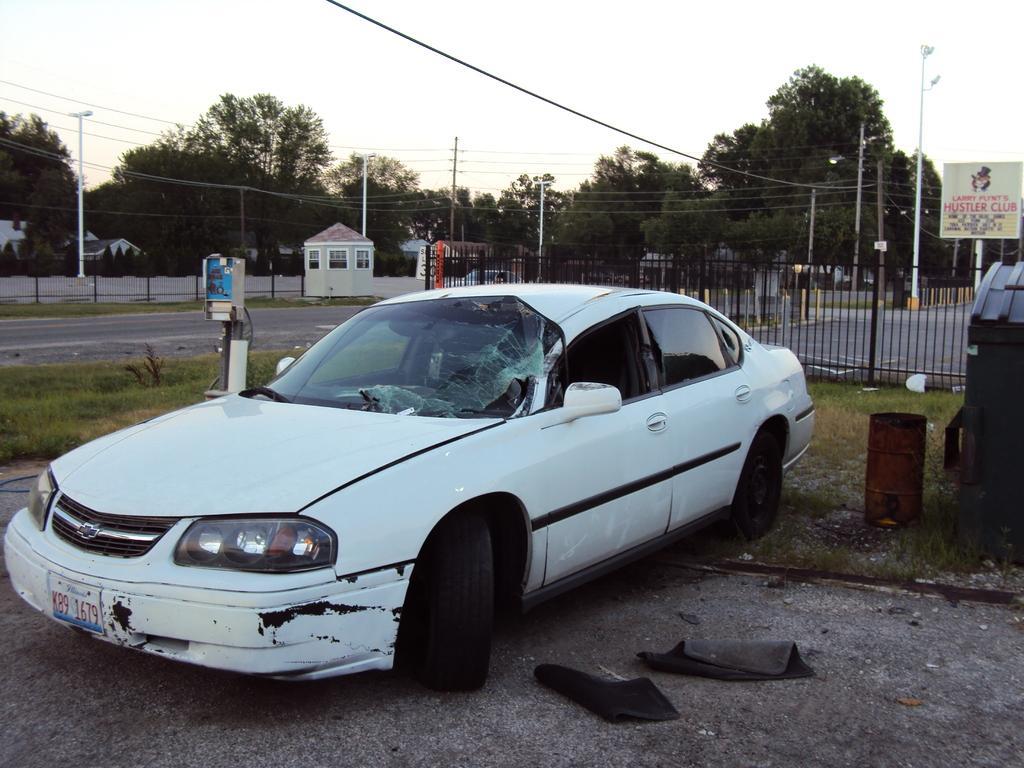Please provide a concise description of this image. There is a car. Near to the car there are carpets. On the ground there is grass. On the right side there is a barrel and a bin. In the back there are railings, electric poles, light poles, roads. In the background there are trees, buildings and sky. Also there is a banner with a pole. 